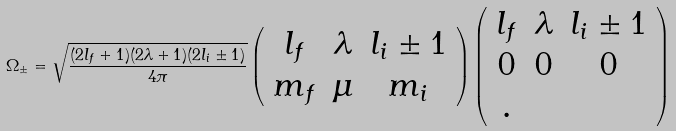<formula> <loc_0><loc_0><loc_500><loc_500>\Omega _ { \pm } = \sqrt { \frac { ( 2 l _ { f } + 1 ) ( 2 \lambda + 1 ) ( 2 l _ { i } \pm 1 ) } { 4 \pi } } \left ( \begin{array} { c c c } l _ { f } & \lambda & l _ { i } \pm 1 \\ m _ { f } & \mu & m _ { i } \\ \end{array} \right ) \left ( \begin{array} { c c c } l _ { f } & \lambda & l _ { i } \pm 1 \\ 0 & 0 & 0 \\ . \end{array} \right )</formula> 